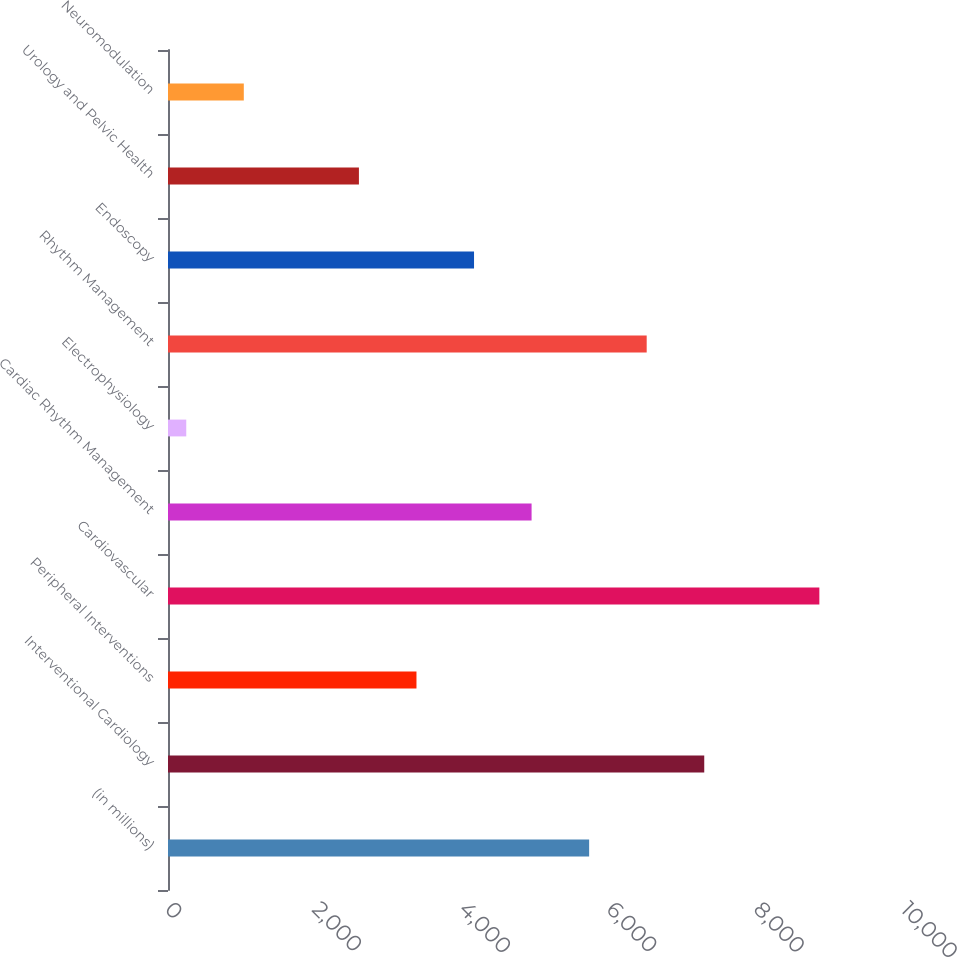Convert chart. <chart><loc_0><loc_0><loc_500><loc_500><bar_chart><fcel>(in millions)<fcel>Interventional Cardiology<fcel>Peripheral Interventions<fcel>Cardiovascular<fcel>Cardiac Rhythm Management<fcel>Electrophysiology<fcel>Rhythm Management<fcel>Endoscopy<fcel>Urology and Pelvic Health<fcel>Neuromodulation<nl><fcel>5722<fcel>7286<fcel>3376<fcel>8850<fcel>4940<fcel>248<fcel>6504<fcel>4158<fcel>2594<fcel>1030<nl></chart> 